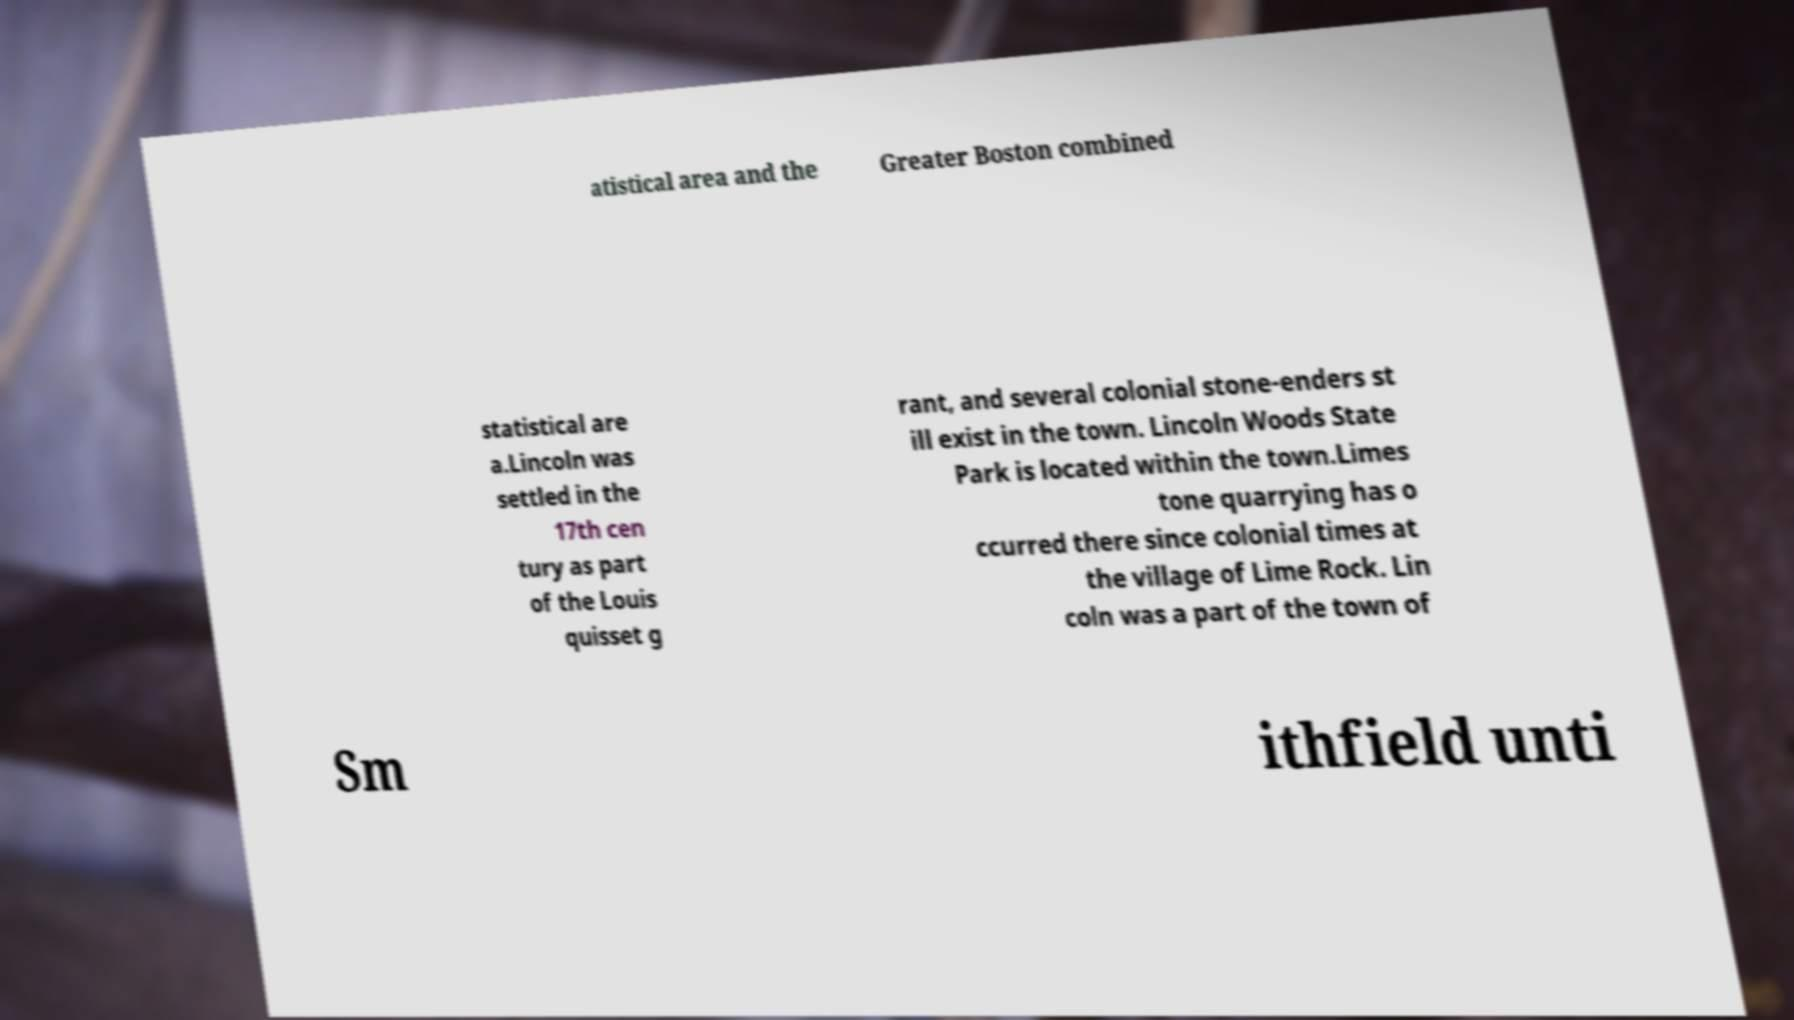Could you assist in decoding the text presented in this image and type it out clearly? atistical area and the Greater Boston combined statistical are a.Lincoln was settled in the 17th cen tury as part of the Louis quisset g rant, and several colonial stone-enders st ill exist in the town. Lincoln Woods State Park is located within the town.Limes tone quarrying has o ccurred there since colonial times at the village of Lime Rock. Lin coln was a part of the town of Sm ithfield unti 